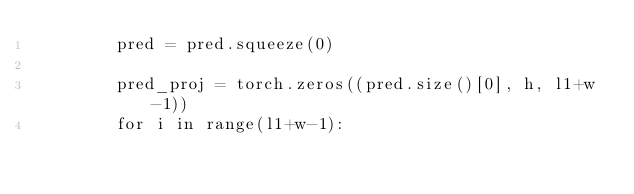<code> <loc_0><loc_0><loc_500><loc_500><_Python_>        pred = pred.squeeze(0)

        pred_proj = torch.zeros((pred.size()[0], h, l1+w-1))
        for i in range(l1+w-1):</code> 